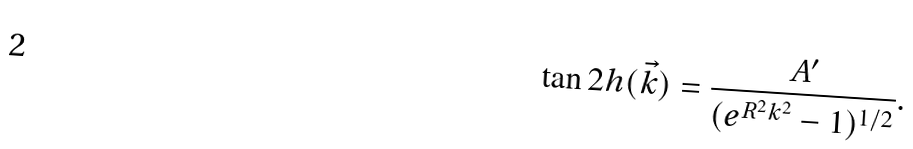<formula> <loc_0><loc_0><loc_500><loc_500>\tan 2 h ( \vec { k } ) = \frac { A ^ { \prime } } { ( e ^ { R ^ { 2 } k ^ { 2 } } - 1 ) ^ { 1 / 2 } } .</formula> 